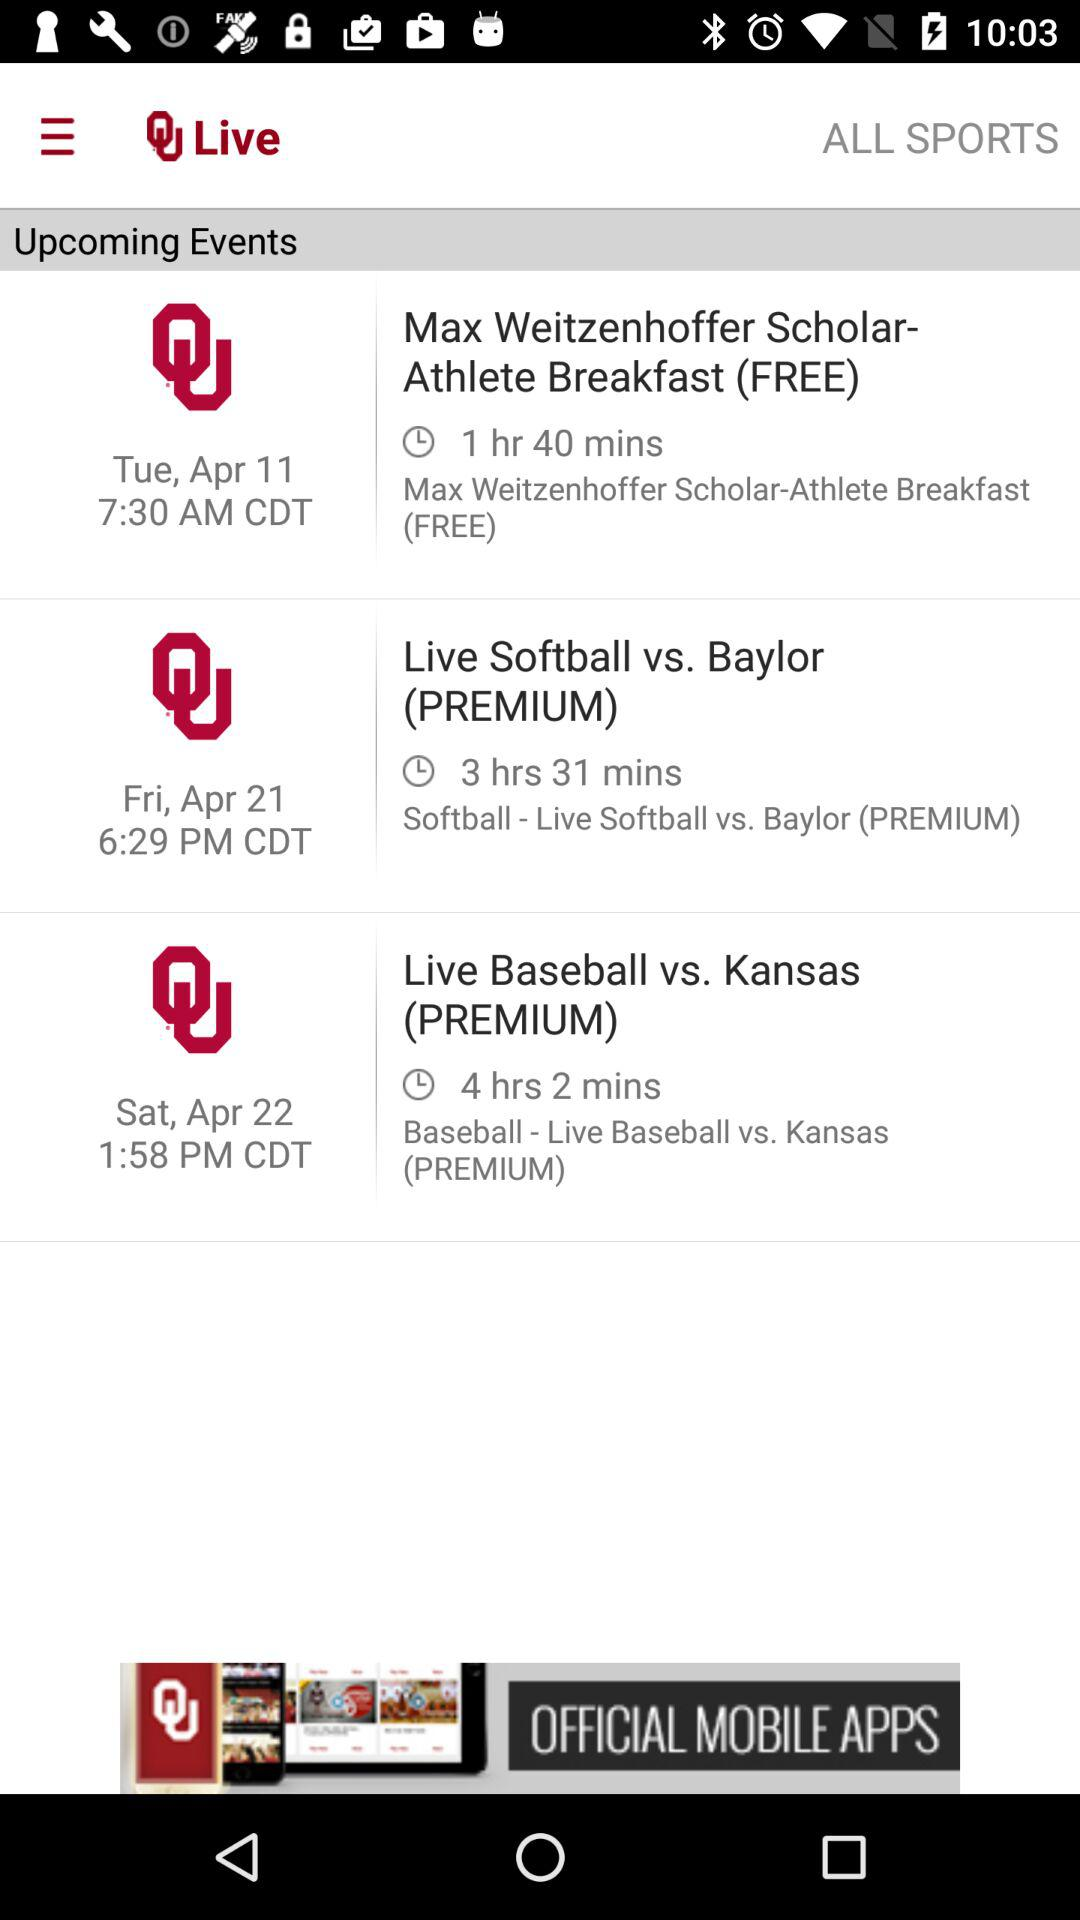When is the "Live Baseball vs. Kansas (PREMIUM)" event scheduled? The "Live Baseball vs. Kansas (PREMIUM)" event is scheduled for Saturday, April 22 at 1:58 p.m. CDT. 